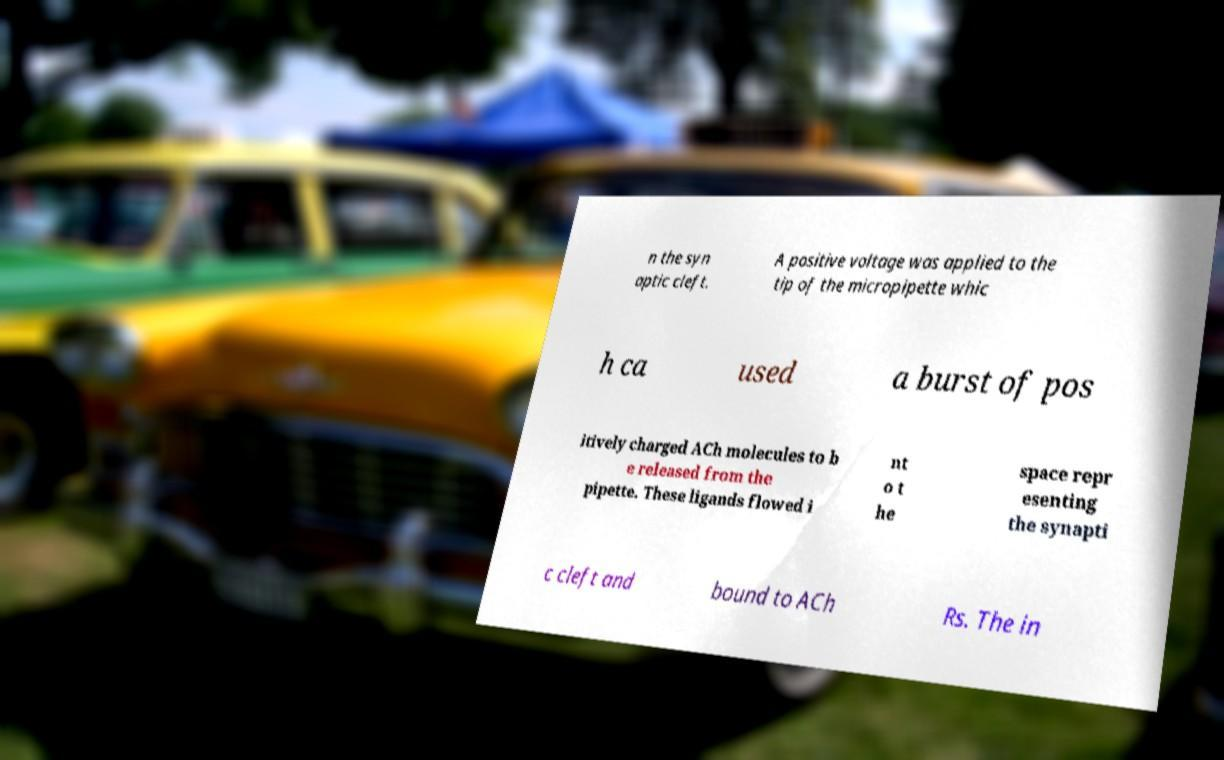There's text embedded in this image that I need extracted. Can you transcribe it verbatim? n the syn aptic cleft. A positive voltage was applied to the tip of the micropipette whic h ca used a burst of pos itively charged ACh molecules to b e released from the pipette. These ligands flowed i nt o t he space repr esenting the synapti c cleft and bound to ACh Rs. The in 